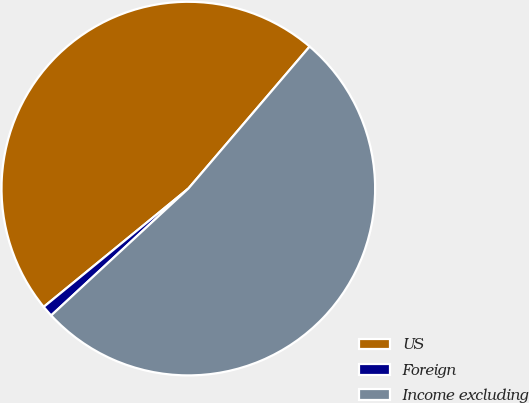<chart> <loc_0><loc_0><loc_500><loc_500><pie_chart><fcel>US<fcel>Foreign<fcel>Income excluding<nl><fcel>47.16%<fcel>0.97%<fcel>51.87%<nl></chart> 